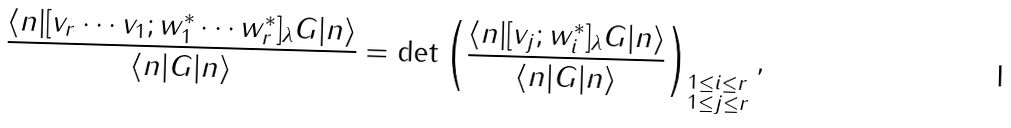Convert formula to latex. <formula><loc_0><loc_0><loc_500><loc_500>\frac { \langle n | [ v _ { r } \cdots v _ { 1 } ; w _ { 1 } ^ { * } \cdots w _ { r } ^ { * } ] _ { \lambda } G | n \rangle } { \langle n | G | n \rangle } = \det \left ( \frac { \langle n | [ v _ { j } ; w _ { i } ^ { * } ] _ { \lambda } G | n \rangle } { \langle n | G | n \rangle } \right ) _ { \begin{subarray} { c } 1 \leq i \leq r \\ 1 \leq j \leq r \end{subarray} } ,</formula> 